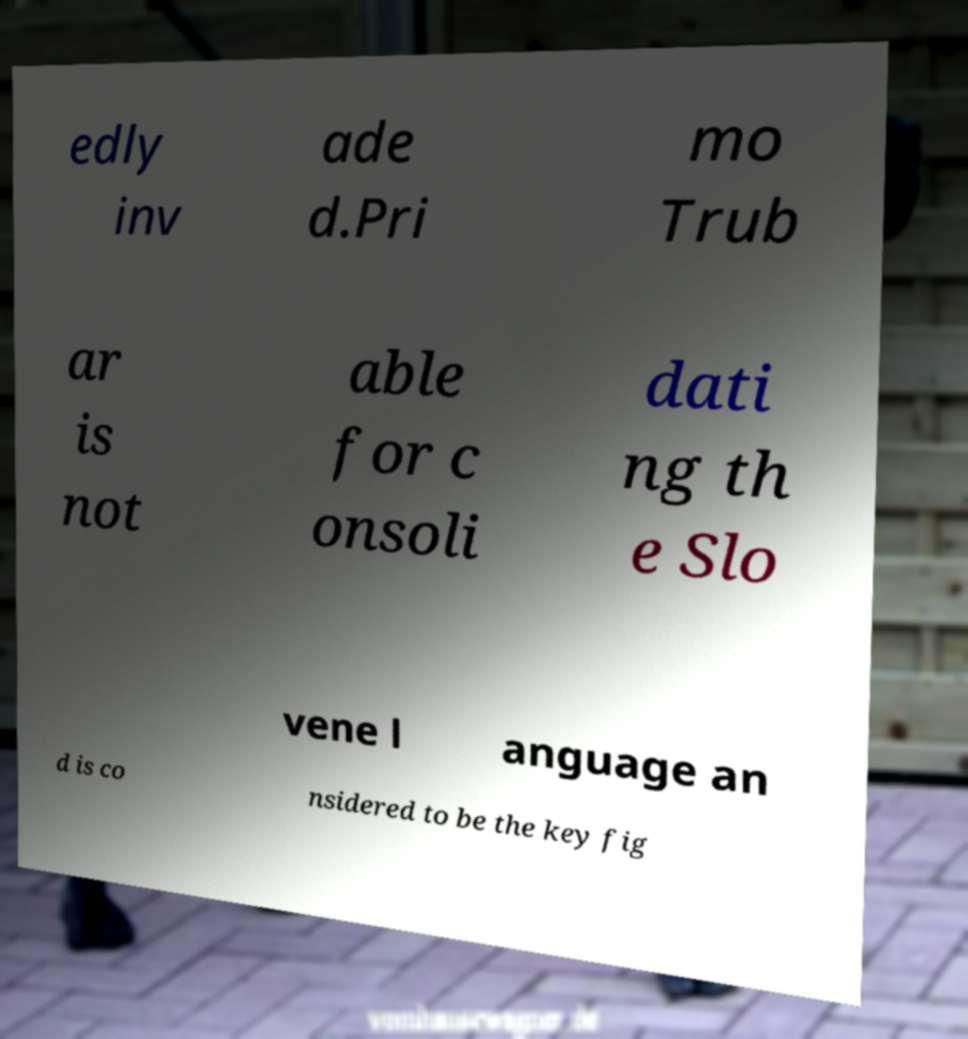Could you extract and type out the text from this image? edly inv ade d.Pri mo Trub ar is not able for c onsoli dati ng th e Slo vene l anguage an d is co nsidered to be the key fig 